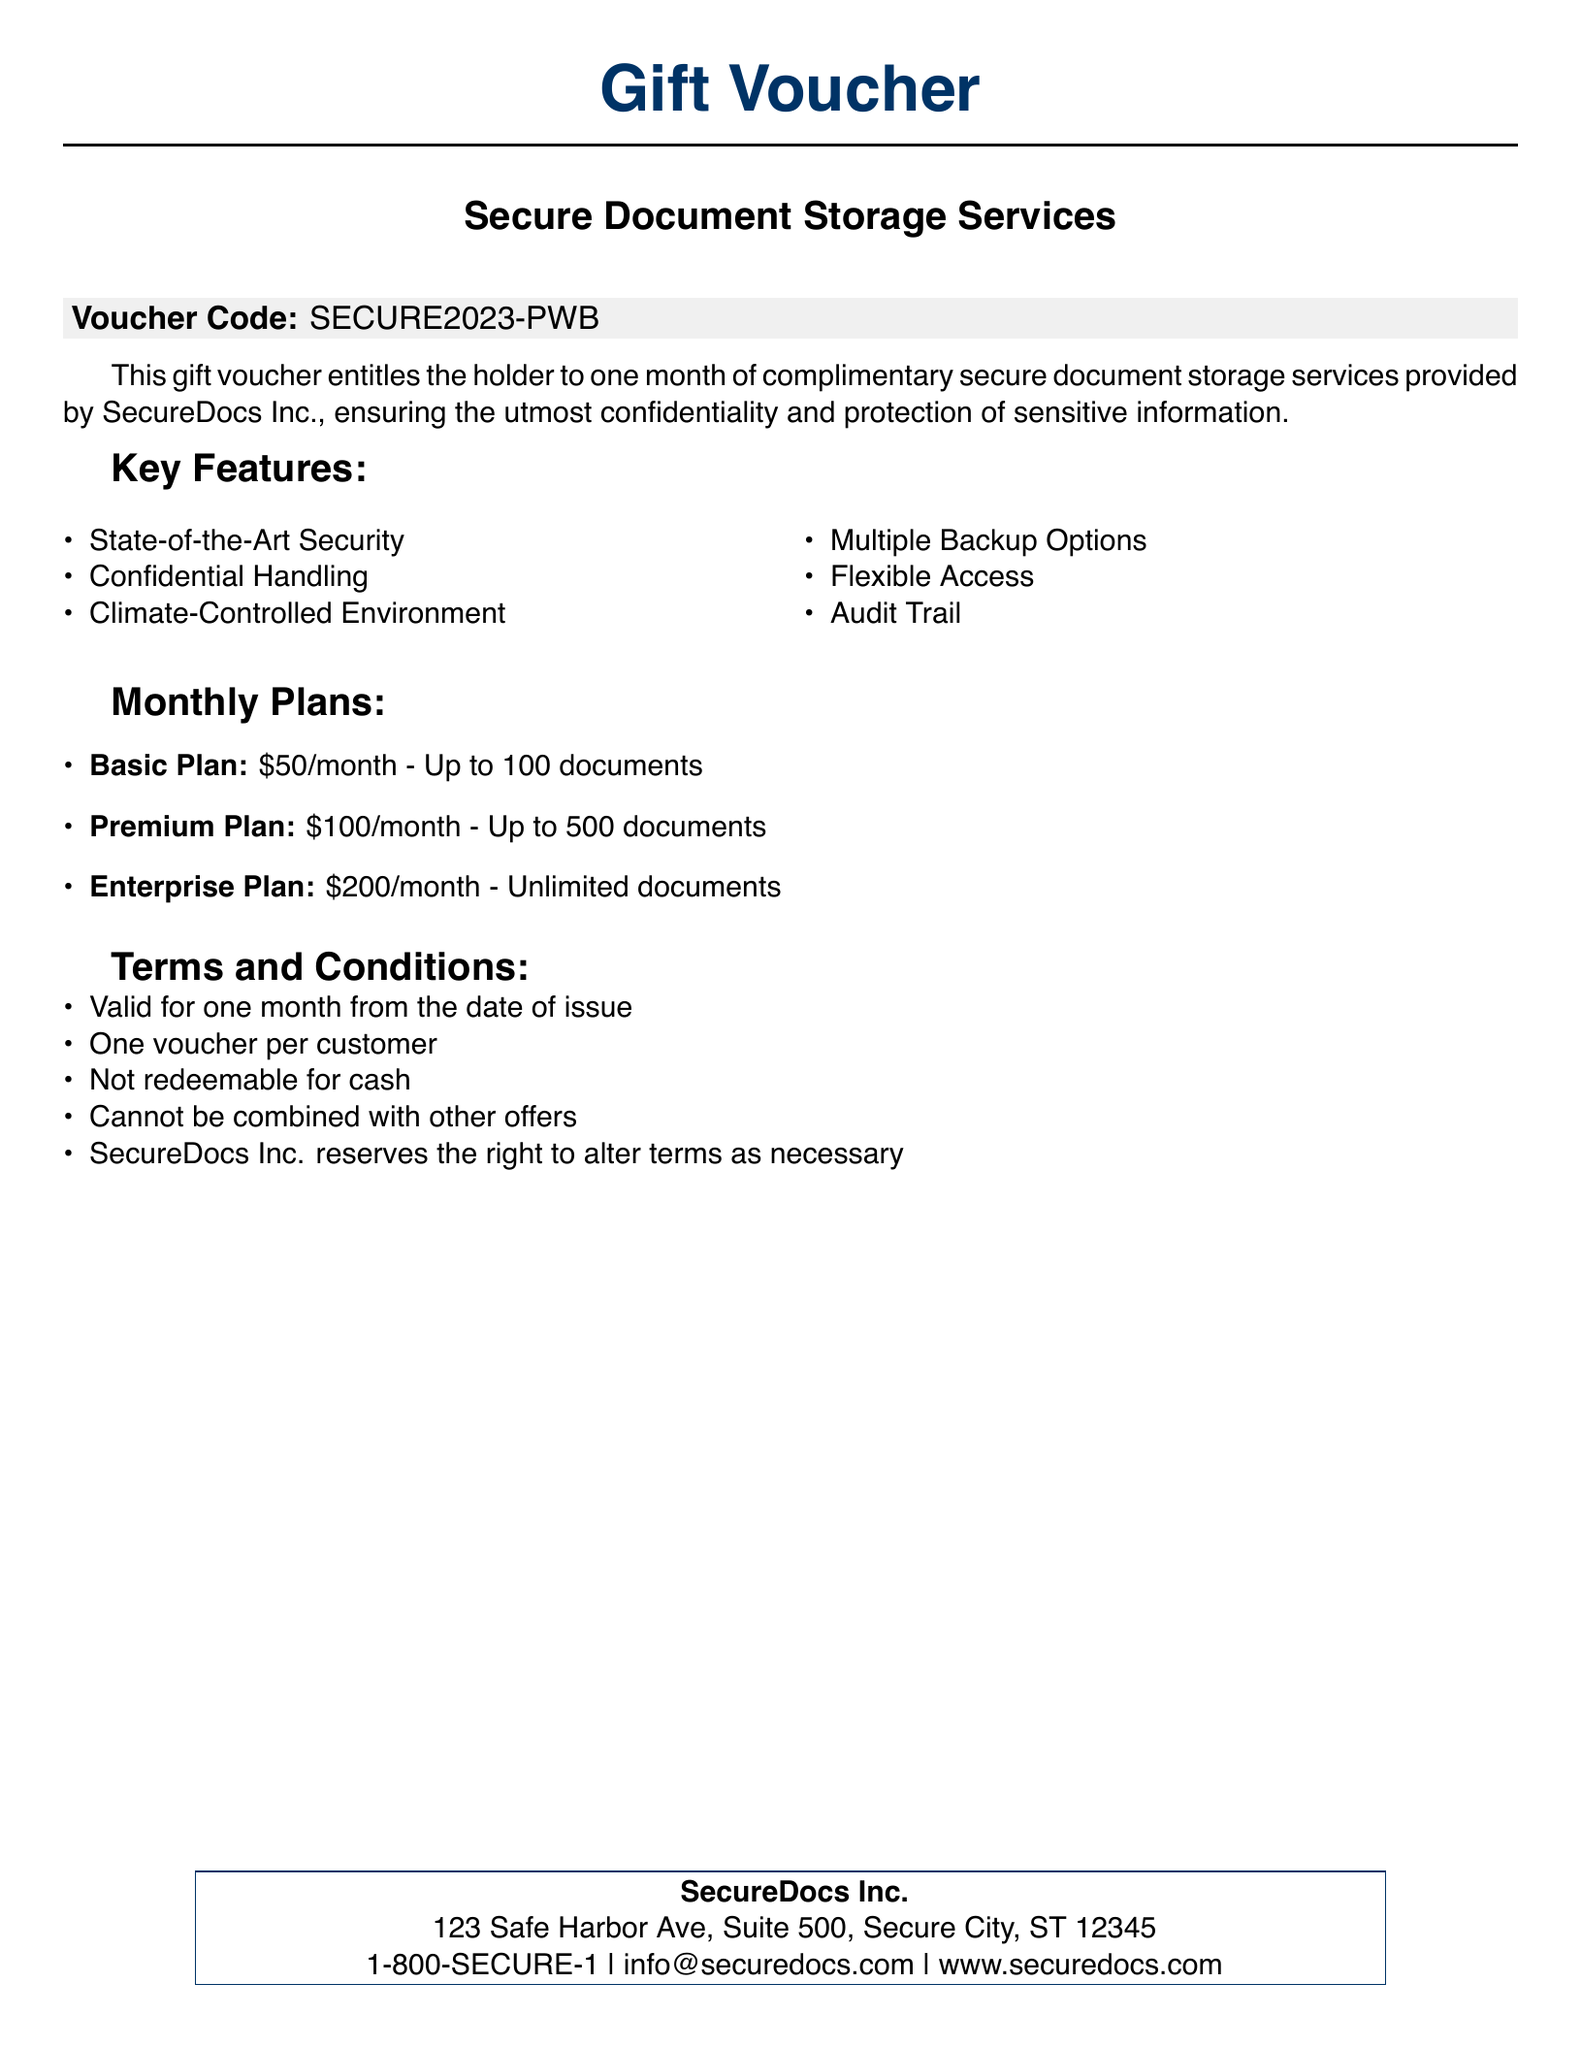What is the voucher code? The voucher code is provided in the document, which is SECURE2023-PWB.
Answer: SECURE2023-PWB How long is the complimentary storage period? The document states the voucher is valid for one month from the date of issue.
Answer: One month What is included in the Premium Plan? The Premium Plan allows up to 500 documents for a monthly fee.
Answer: Up to 500 documents Which feature ensures confidentiality? The document specifies "Confidential Handling" as a feature.
Answer: Confidential Handling What is the monthly fee for the Basic Plan? The Basic Plan fee is explicitly listed in the document as $50/month.
Answer: $50/month How many documents can you store with the Enterprise Plan? The document states that the Enterprise Plan provides unlimited document storage.
Answer: Unlimited documents Can the voucher be combined with other offers? The document mentions that the voucher cannot be combined with other offers.
Answer: No What is the address of SecureDocs Inc.? The address of SecureDocs Inc. is given as 123 Safe Harbor Ave, Suite 500, Secure City, ST 12345.
Answer: 123 Safe Harbor Ave, Suite 500, Secure City, ST 12345 What is one key feature of the storage service? The document lists several features; one example is "State-of-the-Art Security."
Answer: State-of-the-Art Security 